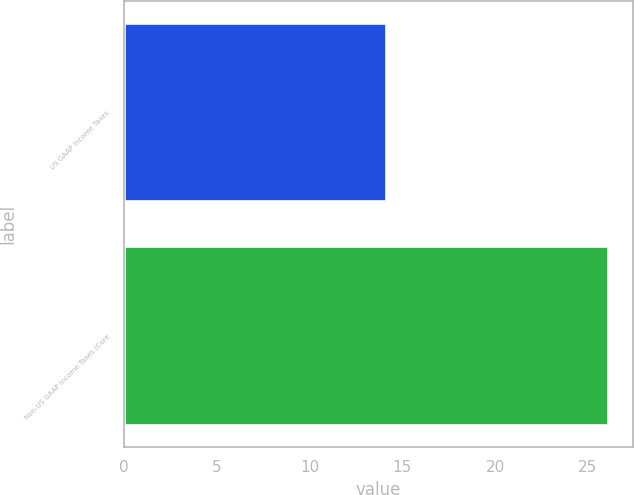Convert chart. <chart><loc_0><loc_0><loc_500><loc_500><bar_chart><fcel>US GAAP Income Taxes<fcel>Non-US GAAP Income Taxes (Core<nl><fcel>14.1<fcel>26.1<nl></chart> 